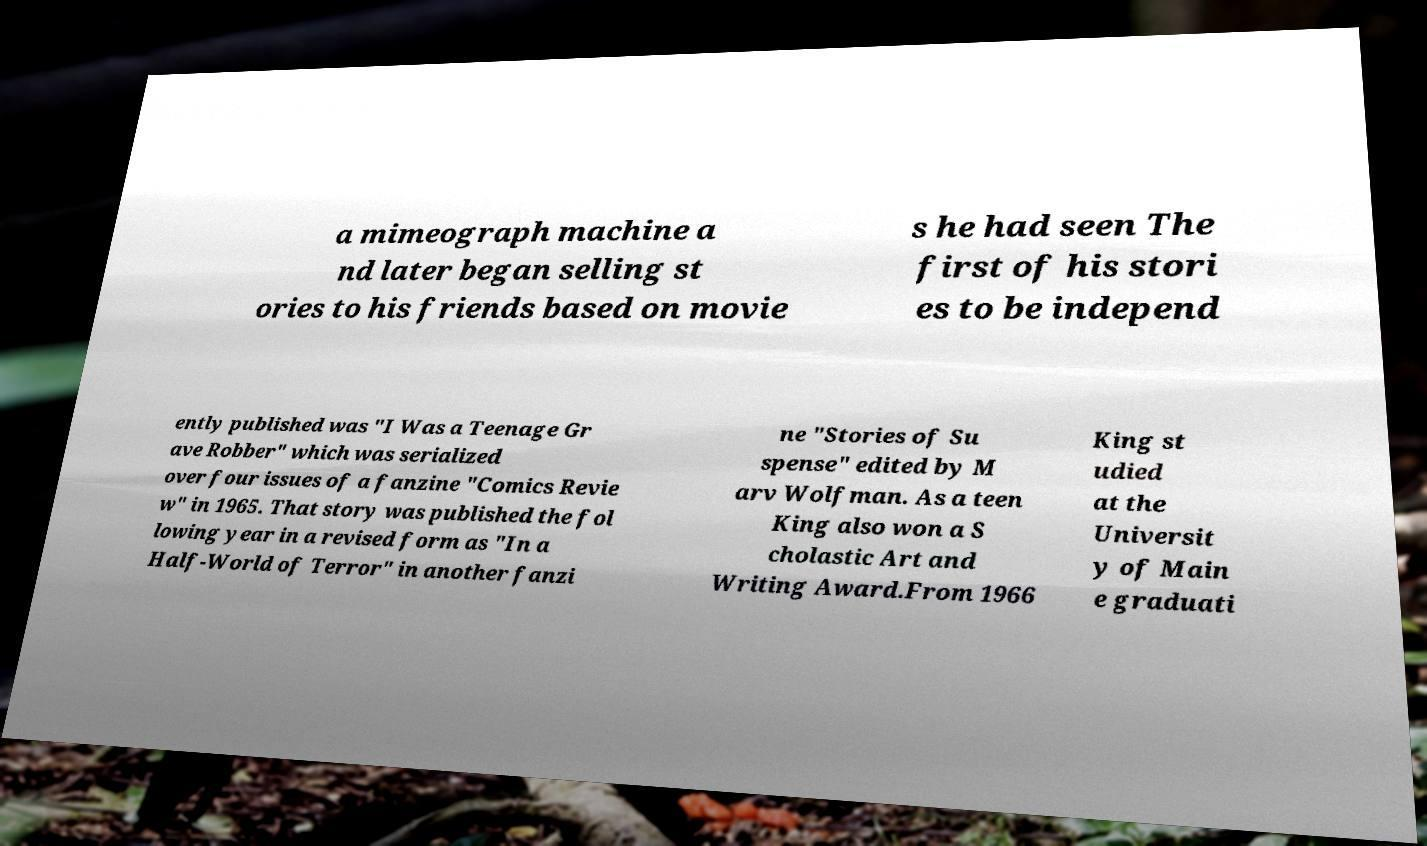I need the written content from this picture converted into text. Can you do that? a mimeograph machine a nd later began selling st ories to his friends based on movie s he had seen The first of his stori es to be independ ently published was "I Was a Teenage Gr ave Robber" which was serialized over four issues of a fanzine "Comics Revie w" in 1965. That story was published the fol lowing year in a revised form as "In a Half-World of Terror" in another fanzi ne "Stories of Su spense" edited by M arv Wolfman. As a teen King also won a S cholastic Art and Writing Award.From 1966 King st udied at the Universit y of Main e graduati 